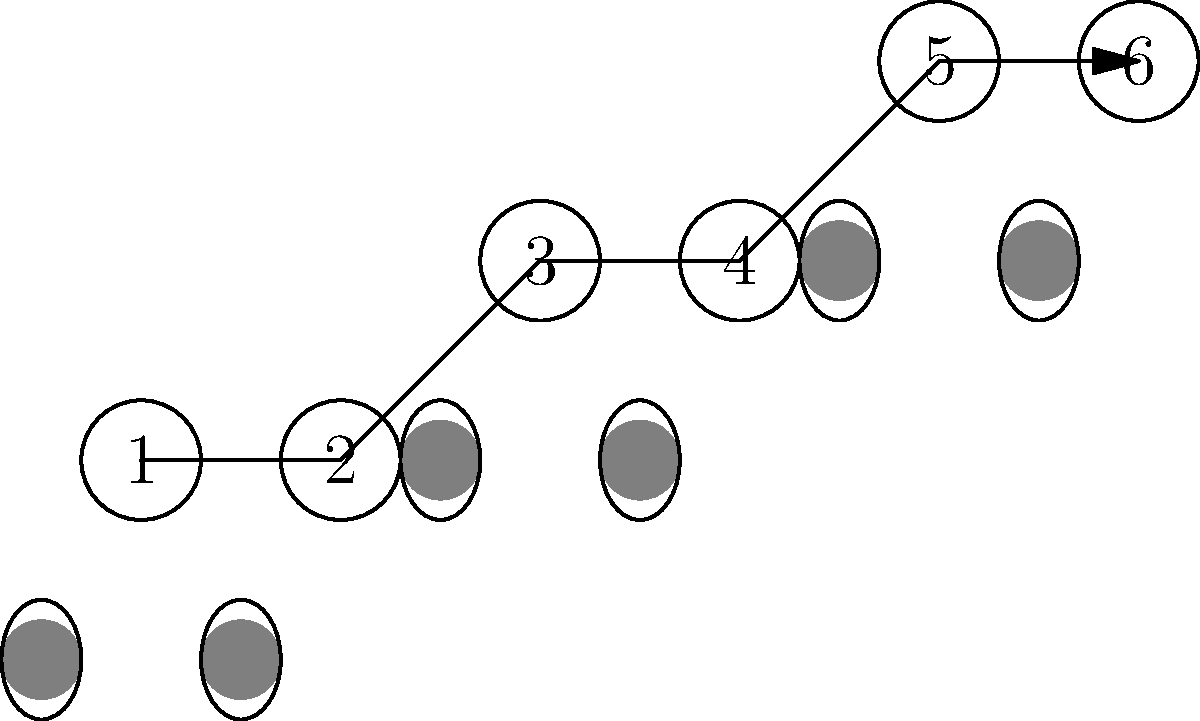The diagram shows a sequence of dance steps represented by numbered circles and corresponding footprint patterns. Which of the following sequences correctly represents the order of steps based on the footprint pattern?

A) 1-2-3-4-5-6
B) 2-1-4-3-6-5
C) 1-2-4-3-5-6
D) 2-1-3-4-6-5 To solve this problem, we need to analyze the footprint pattern and match it with the numbered sequence:

1. The footprints start at the bottom left, corresponding to position 1.
2. The second footprint is to the right of the first, matching the movement from 1 to 2.
3. The third footprint moves up and to the right, corresponding to the step from 2 to 3.
4. The fourth footprint is at the same level as the third, matching the movement from 3 to 4.
5. The fifth footprint moves up again, corresponding to the step from 4 to 5.
6. The final footprint is at the same level as the fifth, matching the movement from 5 to 6.

This analysis shows that the footprint pattern follows the sequence 1-2-3-4-5-6, which matches option A.
Answer: A 